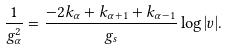<formula> <loc_0><loc_0><loc_500><loc_500>\frac { 1 } { g _ { \alpha } ^ { 2 } } = \frac { - 2 k _ { \alpha } + k _ { \alpha + 1 } + k _ { \alpha - 1 } } { g _ { s } } \log | v | .</formula> 